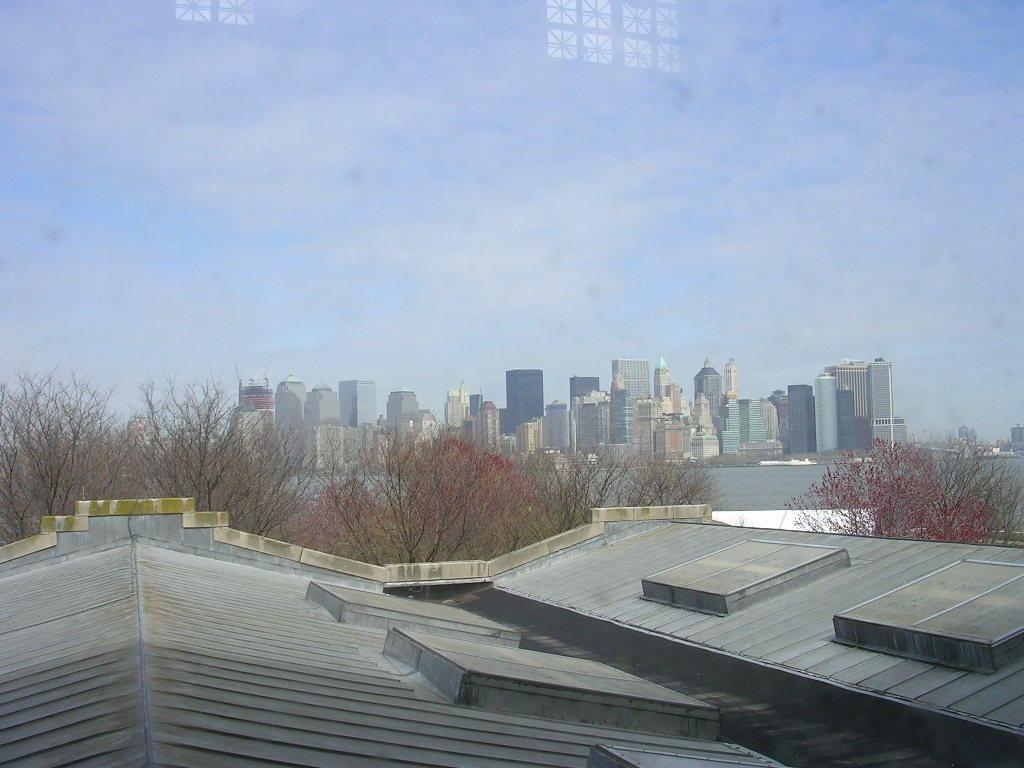What type of structures can be seen in the image? There are buildings and skyscrapers in the image. What natural elements are present in the image? There are trees and water visible in the image. What part of the natural environment is visible in the image? The sky is visible in the image. What type of substance is being added to the lake in the image? There is no lake present in the image, so it is not possible to determine if any substance is being added. 